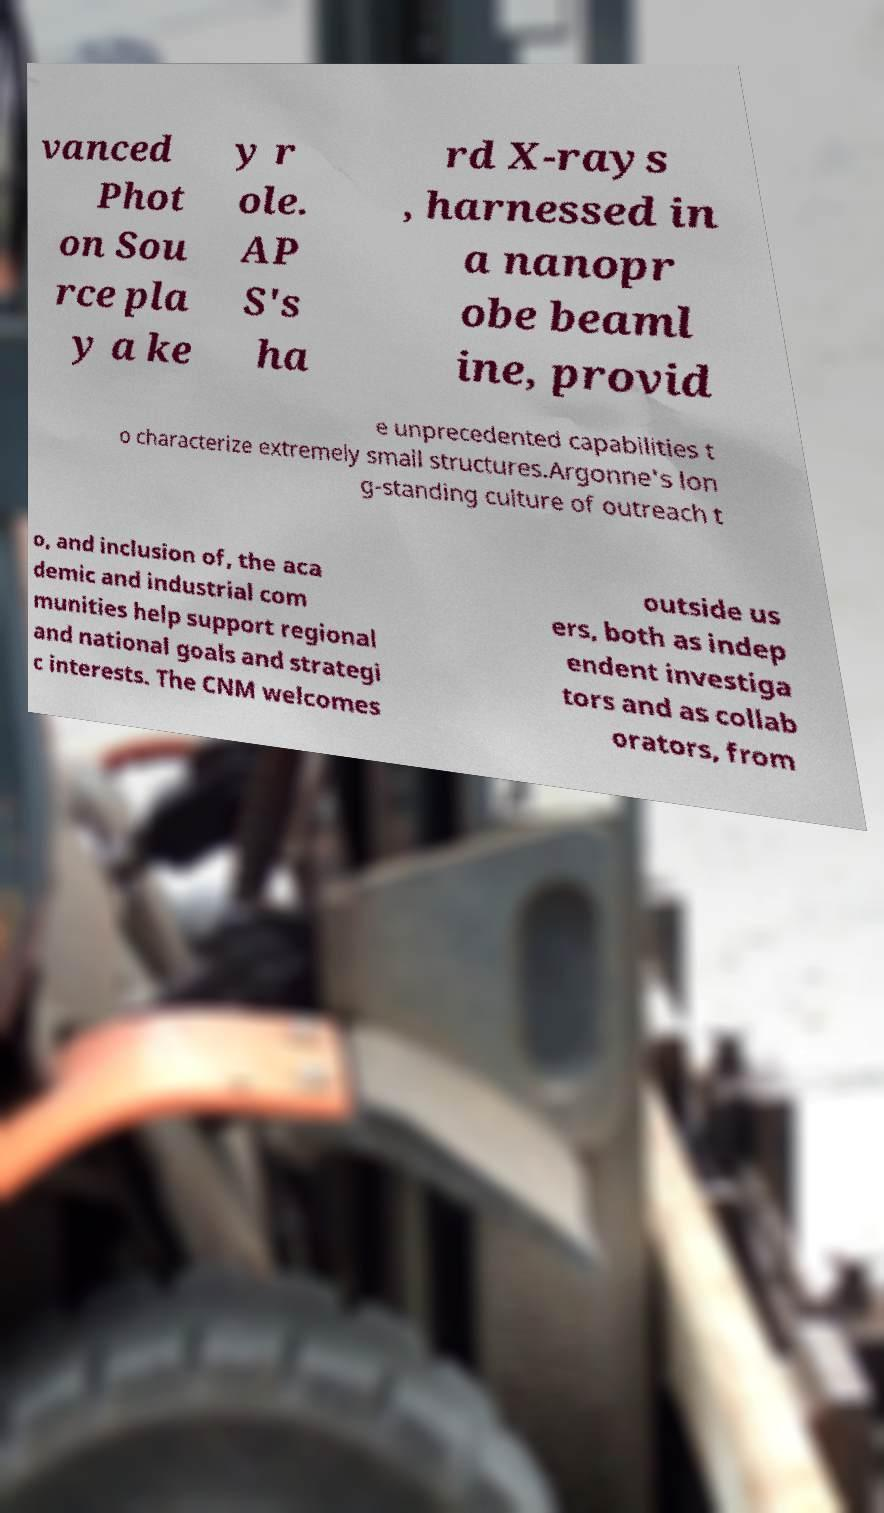Can you accurately transcribe the text from the provided image for me? vanced Phot on Sou rce pla y a ke y r ole. AP S's ha rd X-rays , harnessed in a nanopr obe beaml ine, provid e unprecedented capabilities t o characterize extremely small structures.Argonne's lon g-standing culture of outreach t o, and inclusion of, the aca demic and industrial com munities help support regional and national goals and strategi c interests. The CNM welcomes outside us ers, both as indep endent investiga tors and as collab orators, from 